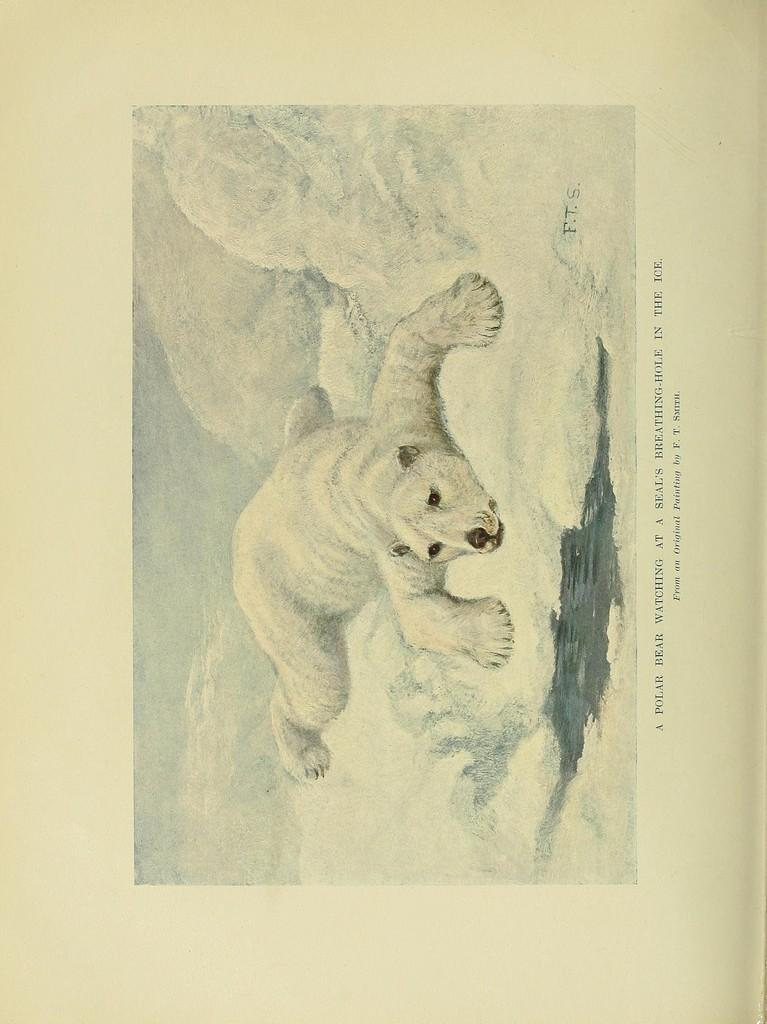What is present in the image that contains a visual representation? There is a poster in the image. What type of image can be seen on the poster? The poster contains a picture of an animal. What else is featured on the poster besides the image? There is text written on the poster. What type of humor can be found in the poster? There is no information about humor in the image or the poster. The poster contains a picture of an animal and text, but no indication of humor. 